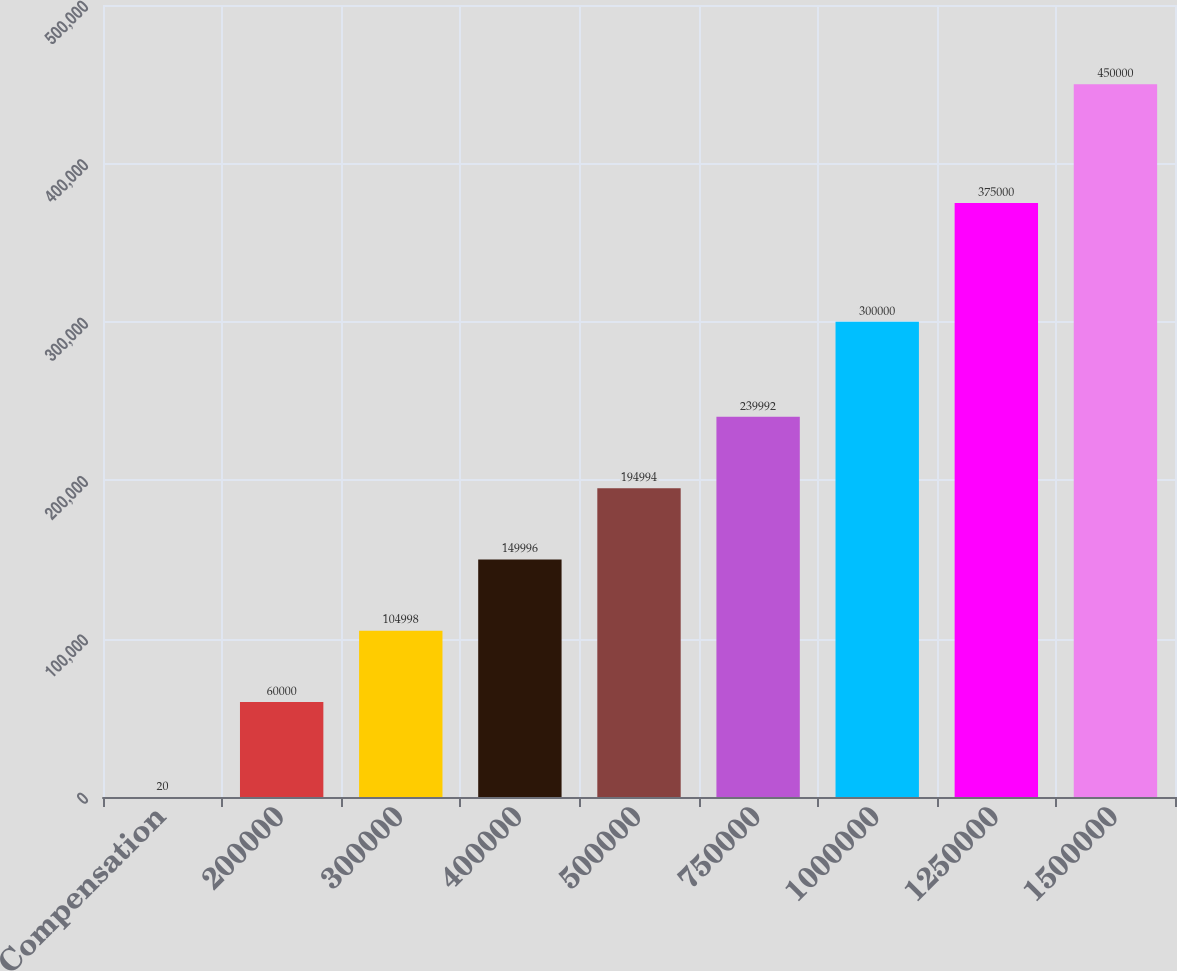<chart> <loc_0><loc_0><loc_500><loc_500><bar_chart><fcel>Compensation<fcel>200000<fcel>300000<fcel>400000<fcel>500000<fcel>750000<fcel>1000000<fcel>1250000<fcel>1500000<nl><fcel>20<fcel>60000<fcel>104998<fcel>149996<fcel>194994<fcel>239992<fcel>300000<fcel>375000<fcel>450000<nl></chart> 